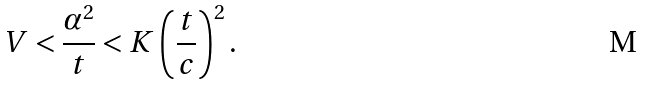Convert formula to latex. <formula><loc_0><loc_0><loc_500><loc_500>V < \frac { \alpha ^ { 2 } } { t } < K \left ( \frac { t } { c } \right ) ^ { 2 } .</formula> 